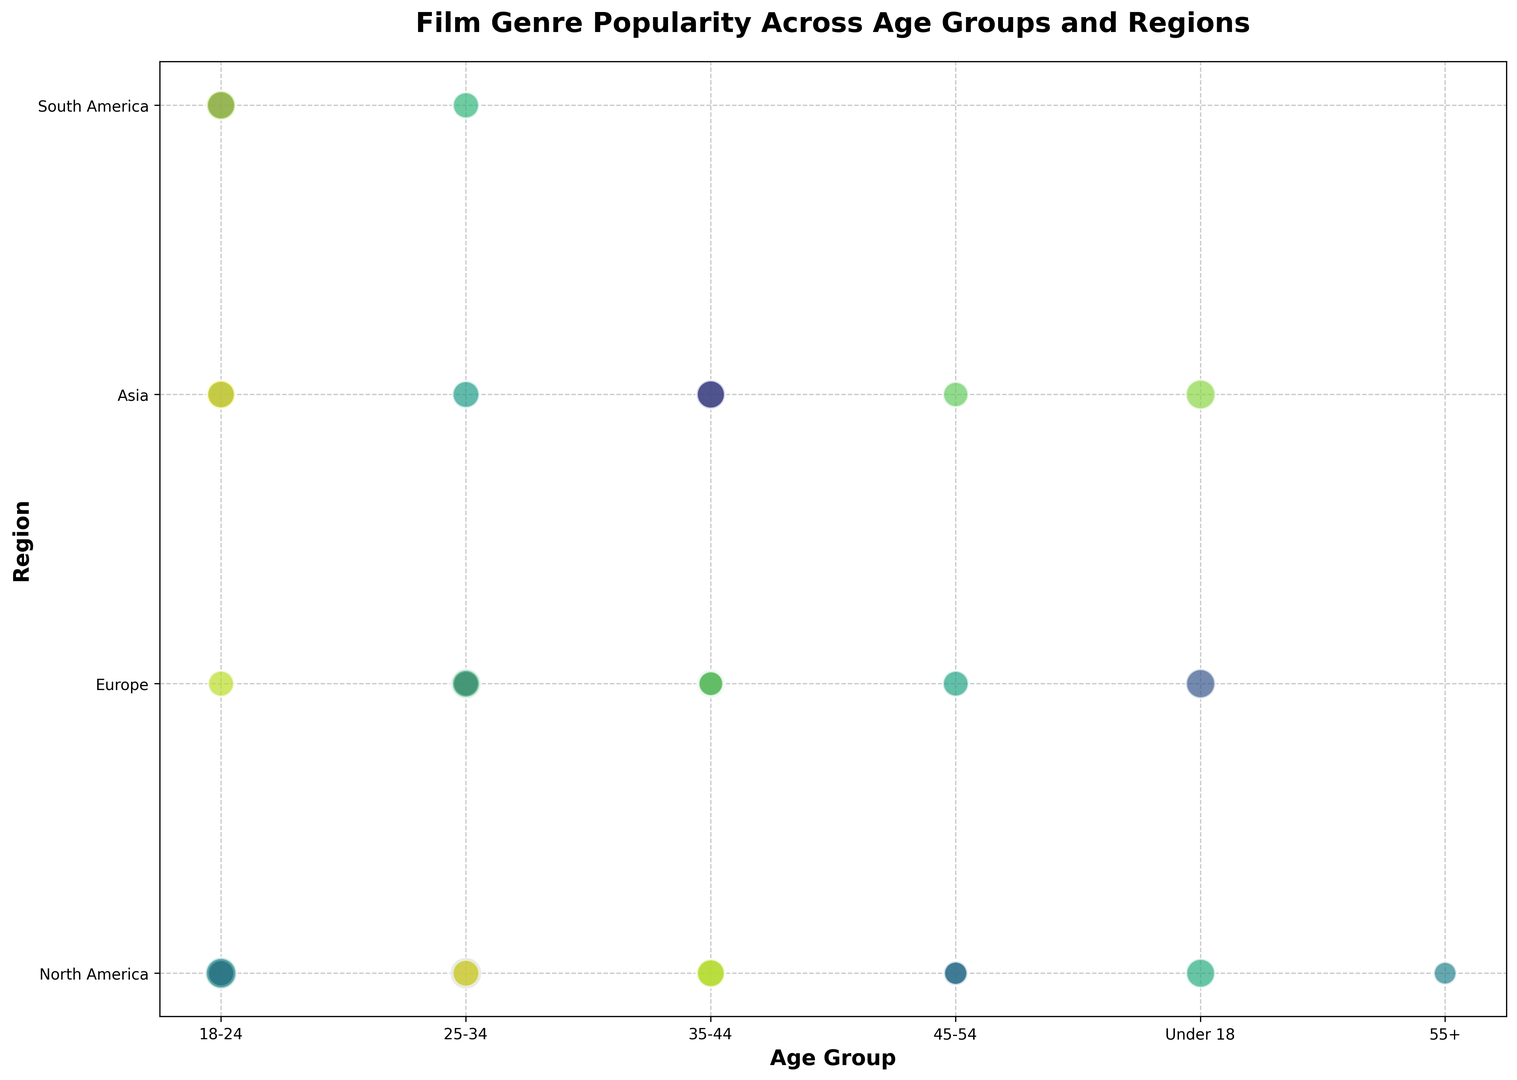Which genre is most popular in the 18-24 age group? For the 18-24 age group, locate the bubbles and identify the one with the largest size. The Action genre in North America is the largest in size.
Answer: Action Which region has the highest average popularity for the genres? Calculate the average popularity for each region's bubbles. North America would have the highest average since its bubbles (Action, Horror, Documentary, etc.) appear visually larger overall.
Answer: North America Is Sci-Fi more popular in South America or is Fantasy more popular in Asia? Compare the bubble sizes for Sci-Fi in South America and Fantasy in Asia. The bubble for Fantasy in Asia is slightly larger, indicating it’s more popular.
Answer: Fantasy in Asia Which age group prefers horror genres the most? Look at the bubbles labeled as Horror and identify the age groups. The bubble representing Horror in North America for the 18-24 age group is the largest.
Answer: 18-24 Which genre is least popular among the 55+ age group? Identify the bubble for the 55+ age group and compare sizes. Only Western is in this group, so it’s the least popular by default.
Answer: Western Compare the popularity of Animated Comedy in Asia with Comedy in Europe. Which is more popular? Look at the bubble sizes for Animated Comedy in Asia and Comedy in Europe. The bubble for Animated Comedy in Asia is larger.
Answer: Animated Comedy in Asia In which region is the genre 'Documentary' the second most popular? Locate bubbles labeled ‘Documentary’ and compare their sizes in different regions. The second largest is in North America.
Answer: North America Identify the genre with the highest popularity in the 35-44 age group. Look at the bubbles for the 35-44 age group and determine which is largest. The Drama bubble in Asia is more prominent than the others.
Answer: Drama What is the popularity difference between Action in North America and Adventure in North America? Note the popularity of Action (85) and Adventure (80) in North America, then subtract. 85 - 80 = 5.
Answer: 5 For the 25-34 age group, rank the top three genres by popularity. Identify and compare the sizes of bubbles in the 25-34 age group and rank the top three. Adventure, Comedy, and Romantic Comedy are the largest respectively.
Answer: Adventure, Comedy, Romantic Comedy 